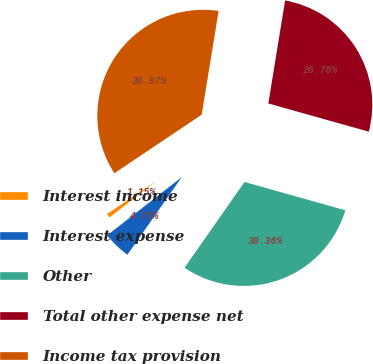<chart> <loc_0><loc_0><loc_500><loc_500><pie_chart><fcel>Interest income<fcel>Interest expense<fcel>Other<fcel>Total other expense net<fcel>Income tax provision<nl><fcel>1.15%<fcel>4.73%<fcel>30.36%<fcel>26.78%<fcel>36.97%<nl></chart> 